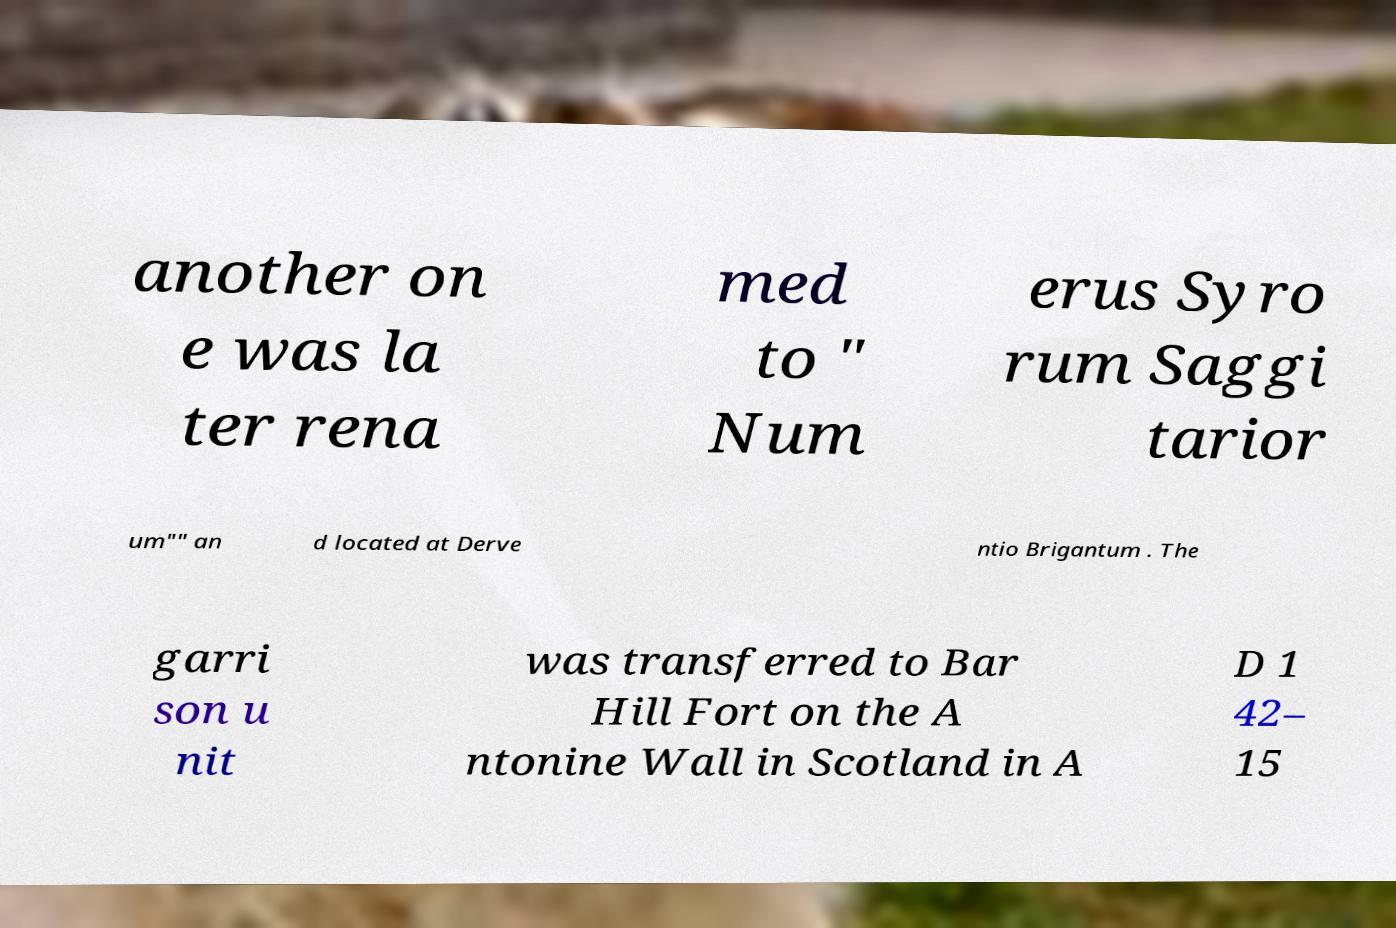Could you assist in decoding the text presented in this image and type it out clearly? another on e was la ter rena med to " Num erus Syro rum Saggi tarior um"" an d located at Derve ntio Brigantum . The garri son u nit was transferred to Bar Hill Fort on the A ntonine Wall in Scotland in A D 1 42– 15 